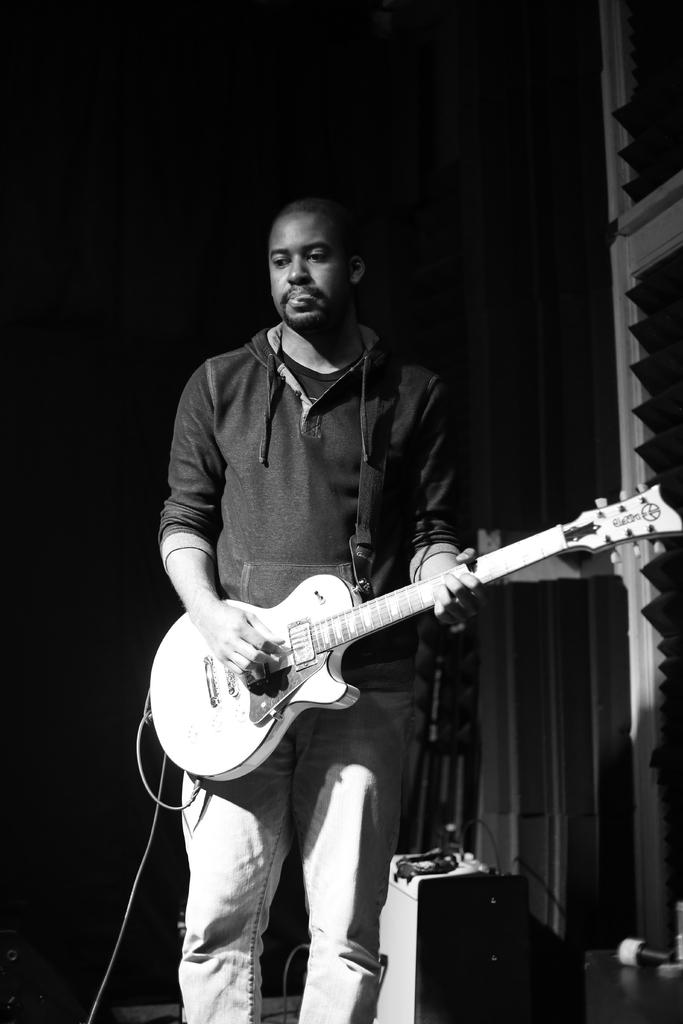Who is the main subject in the image? There is a man in the image. What is the man holding in the image? The man is holding a guitar. What is the man doing with the guitar? The man is playing the guitar. What can be seen in the bottom right corner of the image? There are electronic devices in the bottom right corner of the image. What is present in the top right corner of the image? There is a wall in the top right corner of the image. Reasoning: Let' Let's think step by step in order to produce the conversation. We start by identifying the main subject in the image, which is the man. Then, we describe what the man is holding and doing, which is a guitar and playing it. Next, we mention the electronic devices and the wall, which are also visible in the image. Each question is designed to elicit a specific detail about the image that is known from the provided facts. Absurd Question/Answer: What is the man's mother doing during the guitar performance in the image? There is no indication of the man's mother or any other person in the image, so it cannot be determined what they might be doing. 